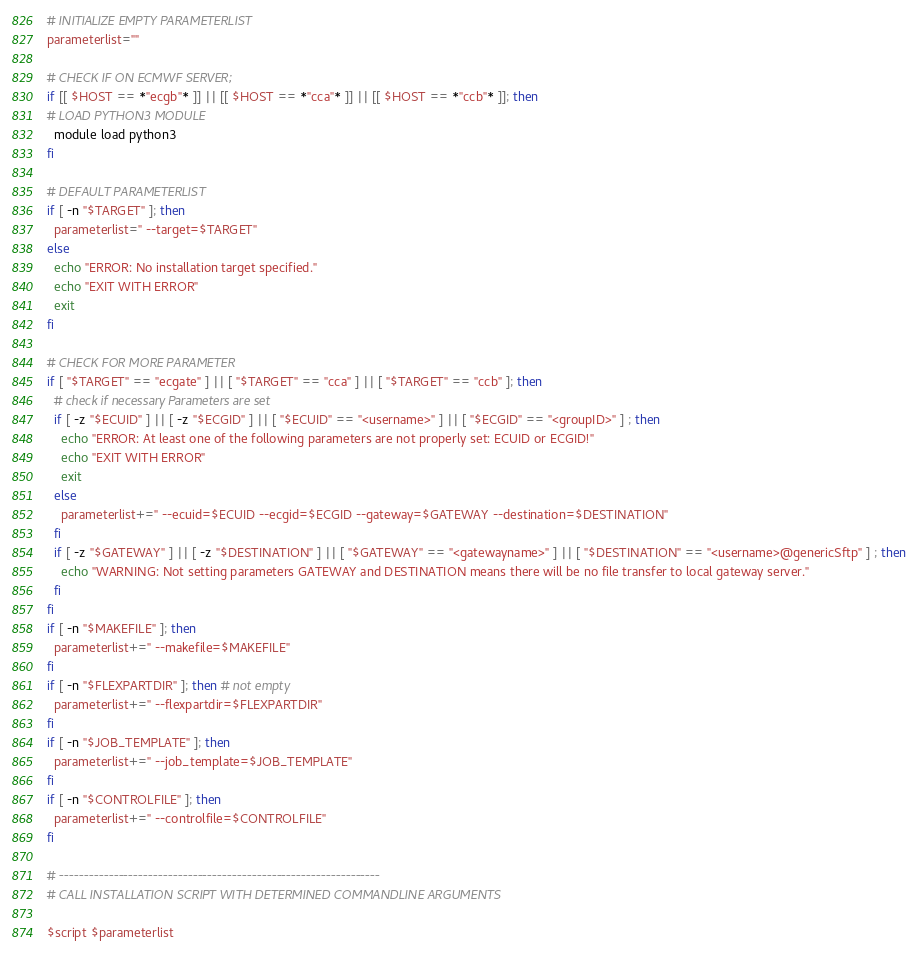<code> <loc_0><loc_0><loc_500><loc_500><_Bash_># INITIALIZE EMPTY PARAMETERLIST
parameterlist=""

# CHECK IF ON ECMWF SERVER; 
if [[ $HOST == *"ecgb"* ]] || [[ $HOST == *"cca"* ]] || [[ $HOST == *"ccb"* ]]; then
# LOAD PYTHON3 MODULE
  module load python3
fi 

# DEFAULT PARAMETERLIST
if [ -n "$TARGET" ]; then
  parameterlist=" --target=$TARGET"
else
  echo "ERROR: No installation target specified."
  echo "EXIT WITH ERROR"
  exit
fi

# CHECK FOR MORE PARAMETER 
if [ "$TARGET" == "ecgate" ] || [ "$TARGET" == "cca" ] || [ "$TARGET" == "ccb" ]; then
  # check if necessary Parameters are set
  if [ -z "$ECUID" ] || [ -z "$ECGID" ] || [ "$ECUID" == "<username>" ] || [ "$ECGID" == "<groupID>" ] ; then
    echo "ERROR: At least one of the following parameters are not properly set: ECUID or ECGID!"
    echo "EXIT WITH ERROR"
    exit
  else
    parameterlist+=" --ecuid=$ECUID --ecgid=$ECGID --gateway=$GATEWAY --destination=$DESTINATION"
  fi
  if [ -z "$GATEWAY" ] || [ -z "$DESTINATION" ] || [ "$GATEWAY" == "<gatewayname>" ] || [ "$DESTINATION" == "<username>@genericSftp" ] ; then
    echo "WARNING: Not setting parameters GATEWAY and DESTINATION means there will be no file transfer to local gateway server."
  fi
fi
if [ -n "$MAKEFILE" ]; then
  parameterlist+=" --makefile=$MAKEFILE"
fi
if [ -n "$FLEXPARTDIR" ]; then # not empty
  parameterlist+=" --flexpartdir=$FLEXPARTDIR"
fi
if [ -n "$JOB_TEMPLATE" ]; then
  parameterlist+=" --job_template=$JOB_TEMPLATE"
fi
if [ -n "$CONTROLFILE" ]; then
  parameterlist+=" --controlfile=$CONTROLFILE"
fi

# -----------------------------------------------------------------
# CALL INSTALLATION SCRIPT WITH DETERMINED COMMANDLINE ARGUMENTS

$script $parameterlist

</code> 